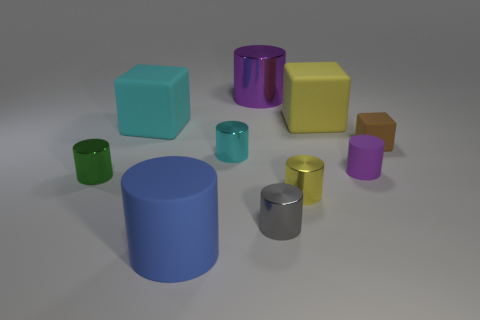Are the big block that is on the left side of the large metallic cylinder and the brown thing made of the same material?
Keep it short and to the point. Yes. How many purple objects are blocks or large matte cylinders?
Keep it short and to the point. 0. Is there a large metallic cylinder of the same color as the tiny matte cylinder?
Your answer should be compact. Yes. Is there a brown ball that has the same material as the big blue cylinder?
Provide a short and direct response. No. What is the shape of the object that is in front of the tiny green metallic thing and on the right side of the tiny gray object?
Provide a succinct answer. Cylinder. What number of large objects are brown metallic spheres or green cylinders?
Your answer should be very brief. 0. What is the large yellow block made of?
Provide a short and direct response. Rubber. What number of other objects are there of the same shape as the tiny purple rubber object?
Provide a succinct answer. 6. The blue rubber cylinder has what size?
Keep it short and to the point. Large. What size is the rubber object that is both on the right side of the large yellow rubber cube and behind the cyan shiny object?
Provide a short and direct response. Small. 